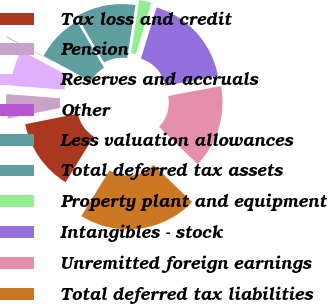Convert chart. <chart><loc_0><loc_0><loc_500><loc_500><pie_chart><fcel>Tax loss and credit<fcel>Pension<fcel>Reserves and accruals<fcel>Other<fcel>Less valuation allowances<fcel>Total deferred tax assets<fcel>Property plant and equipment<fcel>Intangibles - stock<fcel>Unremitted foreign earnings<fcel>Total deferred tax liabilities<nl><fcel>13.01%<fcel>4.4%<fcel>6.56%<fcel>0.1%<fcel>8.71%<fcel>10.86%<fcel>2.25%<fcel>17.32%<fcel>15.17%<fcel>21.62%<nl></chart> 